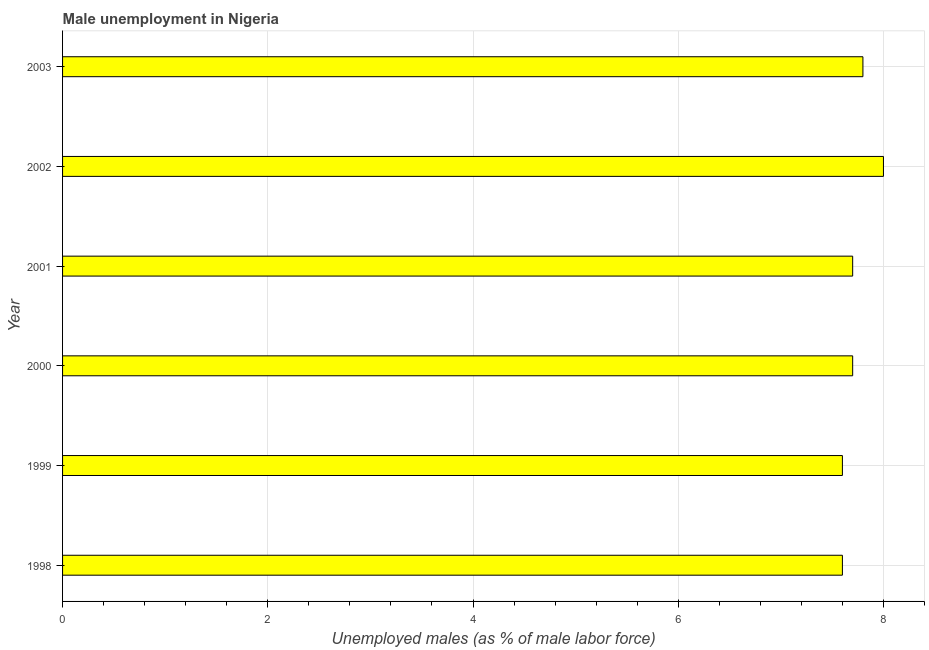What is the title of the graph?
Your answer should be compact. Male unemployment in Nigeria. What is the label or title of the X-axis?
Provide a succinct answer. Unemployed males (as % of male labor force). Across all years, what is the maximum unemployed males population?
Give a very brief answer. 8. Across all years, what is the minimum unemployed males population?
Provide a succinct answer. 7.6. What is the sum of the unemployed males population?
Offer a terse response. 46.4. What is the average unemployed males population per year?
Your response must be concise. 7.73. What is the median unemployed males population?
Make the answer very short. 7.7. In how many years, is the unemployed males population greater than 2 %?
Make the answer very short. 6. Is the difference between the unemployed males population in 1999 and 2002 greater than the difference between any two years?
Offer a very short reply. Yes. What is the difference between the highest and the second highest unemployed males population?
Keep it short and to the point. 0.2. Are all the bars in the graph horizontal?
Keep it short and to the point. Yes. How many years are there in the graph?
Keep it short and to the point. 6. What is the difference between two consecutive major ticks on the X-axis?
Offer a very short reply. 2. What is the Unemployed males (as % of male labor force) of 1998?
Provide a short and direct response. 7.6. What is the Unemployed males (as % of male labor force) in 1999?
Keep it short and to the point. 7.6. What is the Unemployed males (as % of male labor force) in 2000?
Offer a terse response. 7.7. What is the Unemployed males (as % of male labor force) in 2001?
Offer a very short reply. 7.7. What is the Unemployed males (as % of male labor force) of 2003?
Offer a terse response. 7.8. What is the difference between the Unemployed males (as % of male labor force) in 1998 and 1999?
Provide a short and direct response. 0. What is the difference between the Unemployed males (as % of male labor force) in 1998 and 2002?
Offer a terse response. -0.4. What is the difference between the Unemployed males (as % of male labor force) in 1998 and 2003?
Keep it short and to the point. -0.2. What is the difference between the Unemployed males (as % of male labor force) in 1999 and 2002?
Offer a terse response. -0.4. What is the difference between the Unemployed males (as % of male labor force) in 1999 and 2003?
Your answer should be compact. -0.2. What is the difference between the Unemployed males (as % of male labor force) in 2000 and 2001?
Provide a short and direct response. 0. What is the difference between the Unemployed males (as % of male labor force) in 2000 and 2003?
Your answer should be compact. -0.1. What is the difference between the Unemployed males (as % of male labor force) in 2001 and 2002?
Offer a terse response. -0.3. What is the difference between the Unemployed males (as % of male labor force) in 2001 and 2003?
Your response must be concise. -0.1. What is the ratio of the Unemployed males (as % of male labor force) in 1998 to that in 1999?
Provide a short and direct response. 1. What is the ratio of the Unemployed males (as % of male labor force) in 1998 to that in 2000?
Keep it short and to the point. 0.99. What is the ratio of the Unemployed males (as % of male labor force) in 1999 to that in 2000?
Provide a succinct answer. 0.99. What is the ratio of the Unemployed males (as % of male labor force) in 1999 to that in 2001?
Your answer should be compact. 0.99. What is the ratio of the Unemployed males (as % of male labor force) in 1999 to that in 2003?
Provide a short and direct response. 0.97. What is the ratio of the Unemployed males (as % of male labor force) in 2000 to that in 2002?
Provide a succinct answer. 0.96. What is the ratio of the Unemployed males (as % of male labor force) in 2001 to that in 2003?
Provide a short and direct response. 0.99. What is the ratio of the Unemployed males (as % of male labor force) in 2002 to that in 2003?
Your answer should be very brief. 1.03. 